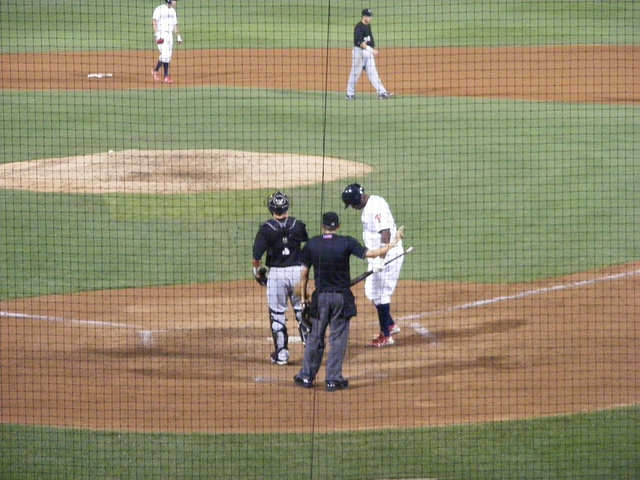Describe the objects in this image and their specific colors. I can see people in gray, black, and tan tones, people in gray, white, darkgray, and black tones, people in gray, black, lavender, and darkgray tones, people in gray, lavender, darkgray, and tan tones, and people in gray, white, darkgray, and tan tones in this image. 